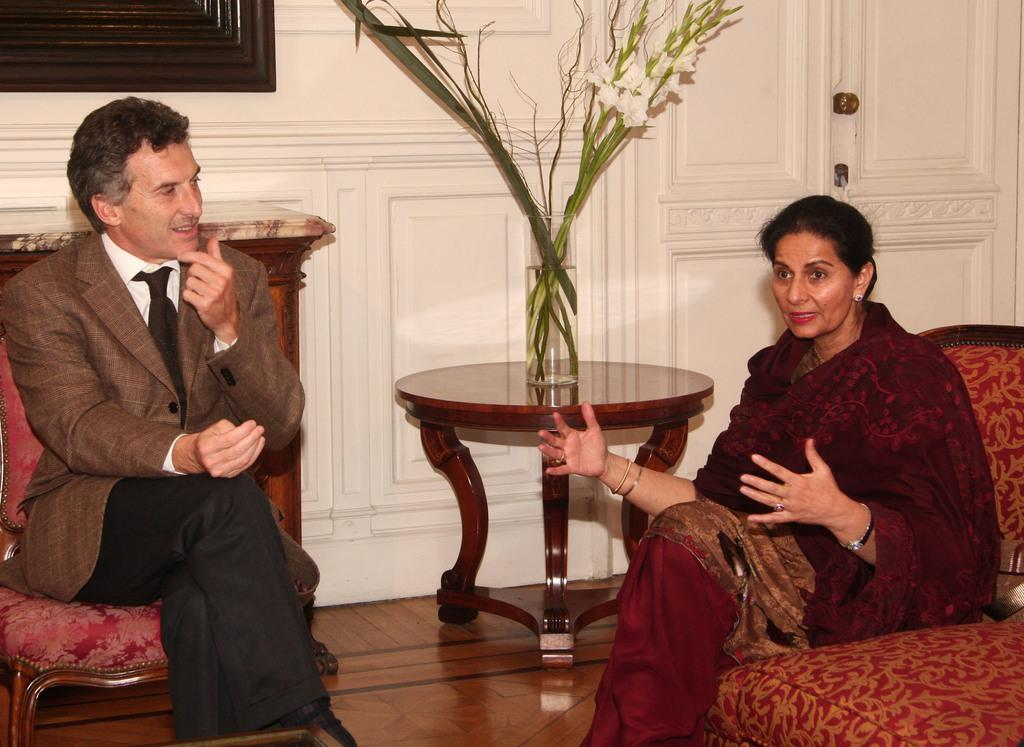How many people are in the image? There are two people in the image. What are the people doing in the image? The people are sitting on chairs. What can be seen on the table in the image? There is a wooden table in the image, and a flower vase is on the table. What is the color of the wall in the background? The background of the image includes a white-colored wall. What is the color and material of the frame in the background? There is a brown-colored frame in the background. What type of stew is being served in the image? There is no stew present in the image. Can you hear the thunder in the image? There is no sound or indication of thunder in the image. 